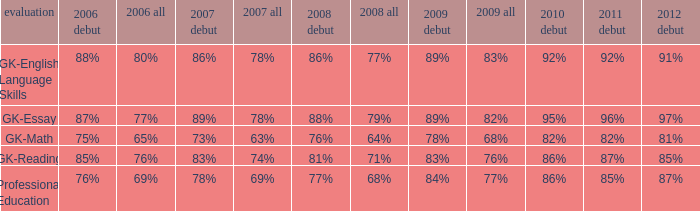What is the percentage for first time 2011 when the first time in 2009 is 68%? 82%. 